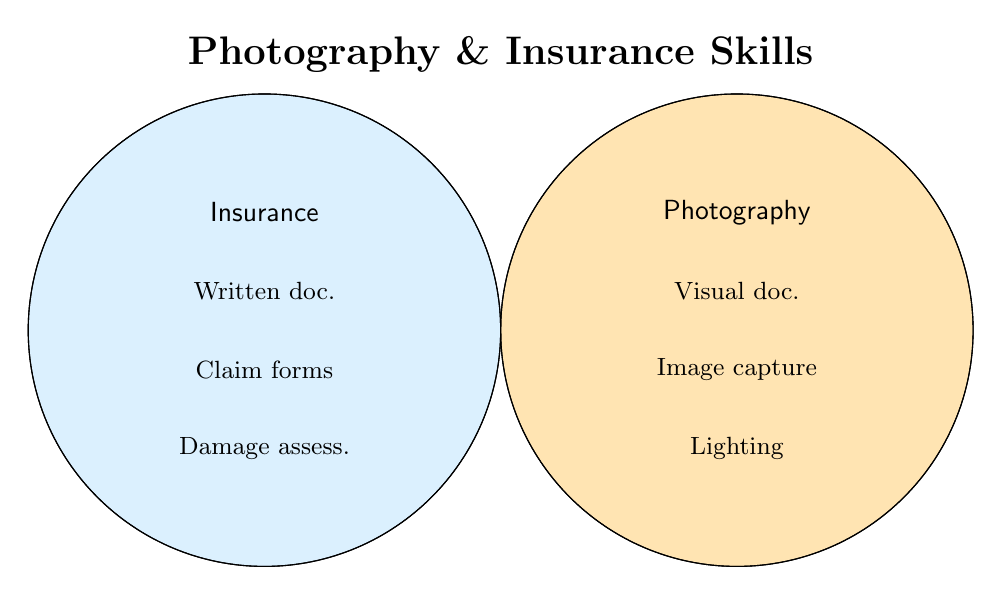What are the main skills listed under Photography? Look at the circle labeled "Photography" to find the key skills in it. They include Visual documentation, Capturing images, and Lighting techniques.
Answer: Visual documentation, Capturing images, Lighting techniques What skills are shared between Photography and Insurance Documentation? Notice the overlapping area between the Photography and Insurance circles. The shared skills include Attention to detail, Digital file management, and Evidence preservation.
Answer: Attention to detail, Digital file management, Evidence preservation What is one skill unique to Insurance Documentation but not shared with Photography? To find an Insurance documentation-only skill, look at the non-overlapping part of the Insurance Documentation circle. One such skill is Claim form completion.
Answer: Claim form completion How many skills are exclusive to Photography? Count the non-overlapping skills in the Photography circle. They are Visual documentation, Capturing images, Lighting techniques, Composition skills, Equipment knowledge, Scene assessment, and Post-processing, totaling to 7.
Answer: 7 Which skill can be linked to both Organizing information in Photography and Categorizing damages in Insurance Documentation? The overlapping section will give us this information. The skill linking these could be evidenced by the shared organizational focus, which could be Digital file management.
Answer: Organizing information and Categorizing damages Which skill related to Insurance Documentation involves chronological tracking? Look at the individual skills listed under Insurance Documentation, and find the one related to chronological tracking. This is Time-stamping.
Answer: Time-stamping What is the combined number of skills in the overlapping area plus those unique to Photography? Add the number of overlapping skills (3) to the number of unique Photography skills (7). This totals 10 skills.
Answer: 10 